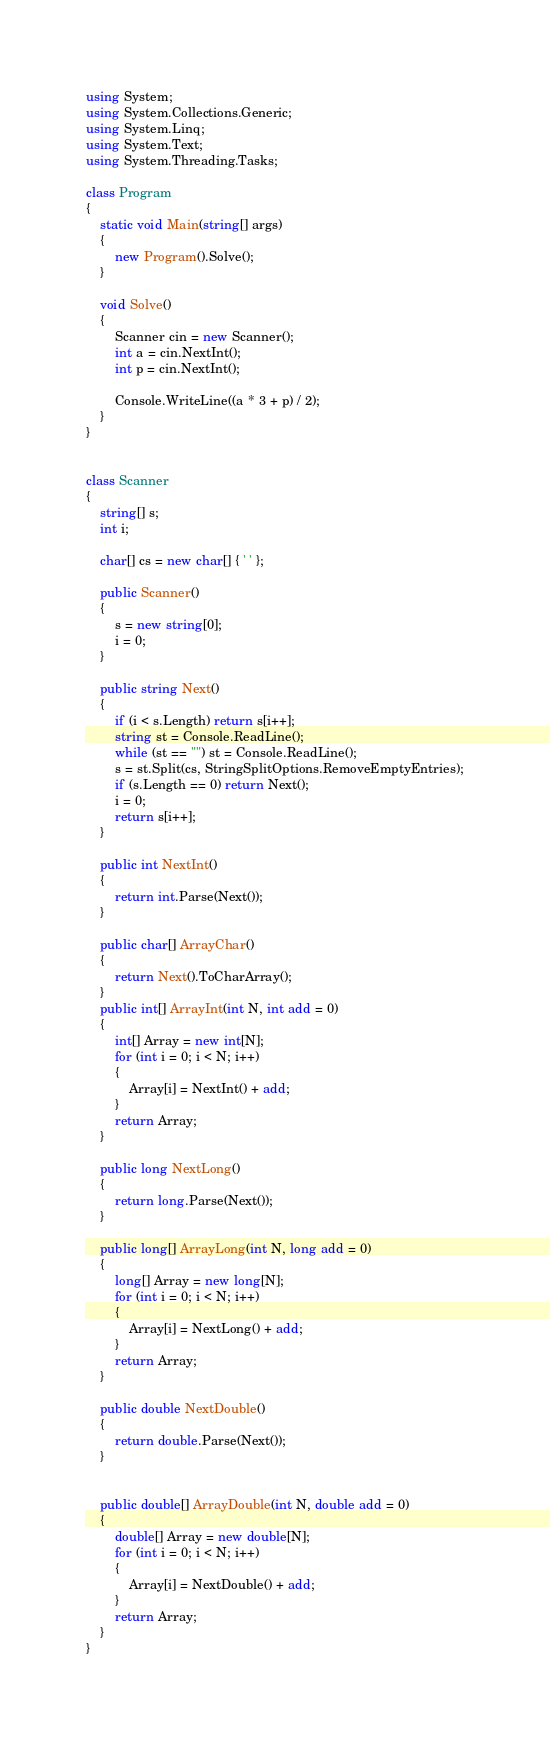<code> <loc_0><loc_0><loc_500><loc_500><_C#_>using System;
using System.Collections.Generic;
using System.Linq;
using System.Text;
using System.Threading.Tasks;

class Program
{
    static void Main(string[] args)
    {
        new Program().Solve();
    }

    void Solve()
    {
        Scanner cin = new Scanner();
        int a = cin.NextInt();
        int p = cin.NextInt();

        Console.WriteLine((a * 3 + p) / 2);
    }
}


class Scanner
{
    string[] s;
    int i;

    char[] cs = new char[] { ' ' };

    public Scanner()
    {
        s = new string[0];
        i = 0;
    }

    public string Next()
    {
        if (i < s.Length) return s[i++];
        string st = Console.ReadLine();
        while (st == "") st = Console.ReadLine();
        s = st.Split(cs, StringSplitOptions.RemoveEmptyEntries);
        if (s.Length == 0) return Next();
        i = 0;
        return s[i++];
    }

    public int NextInt()
    {
        return int.Parse(Next());
    }

    public char[] ArrayChar()
    {
        return Next().ToCharArray();
    }
    public int[] ArrayInt(int N, int add = 0)
    {
        int[] Array = new int[N];
        for (int i = 0; i < N; i++)
        {
            Array[i] = NextInt() + add;
        }
        return Array;
    }

    public long NextLong()
    {
        return long.Parse(Next());
    }

    public long[] ArrayLong(int N, long add = 0)
    {
        long[] Array = new long[N];
        for (int i = 0; i < N; i++)
        {
            Array[i] = NextLong() + add;
        }
        return Array;
    }

    public double NextDouble()
    {
        return double.Parse(Next());
    }


    public double[] ArrayDouble(int N, double add = 0)
    {
        double[] Array = new double[N];
        for (int i = 0; i < N; i++)
        {
            Array[i] = NextDouble() + add;
        }
        return Array;
    }
}</code> 